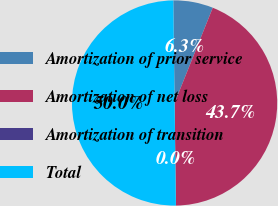Convert chart to OTSL. <chart><loc_0><loc_0><loc_500><loc_500><pie_chart><fcel>Amortization of prior service<fcel>Amortization of net loss<fcel>Amortization of transition<fcel>Total<nl><fcel>6.27%<fcel>43.73%<fcel>0.0%<fcel>50.0%<nl></chart> 